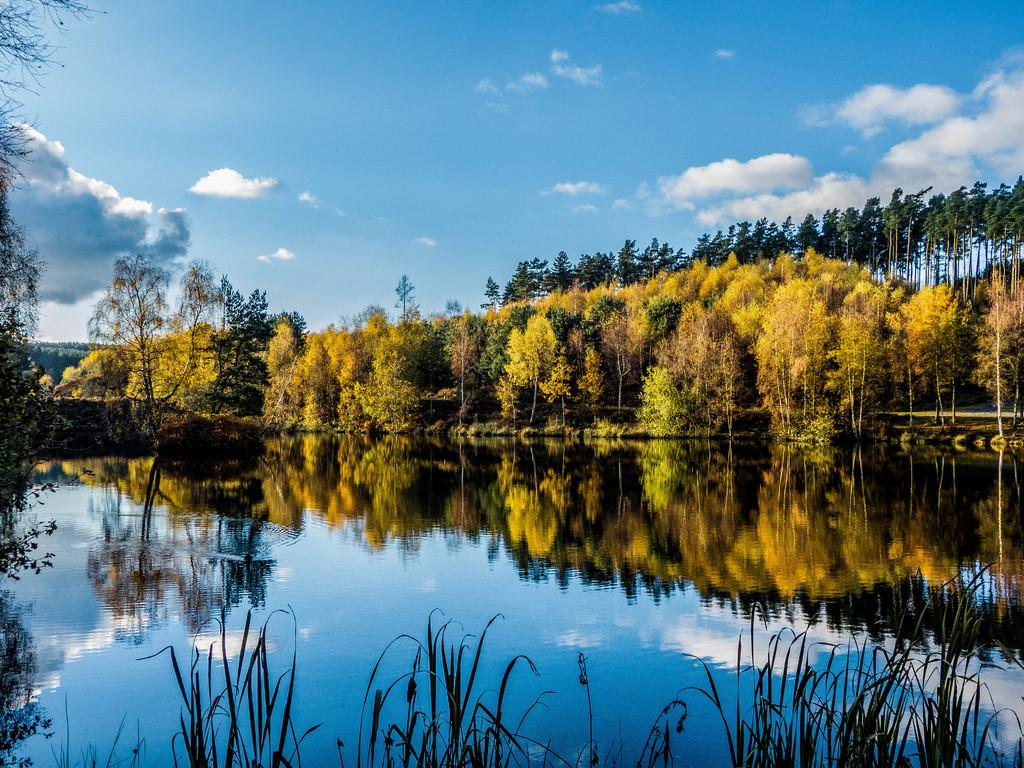What is visible in the image? Water is visible in the image. What can be seen in the background of the image? There are trees in the background of the image. What is the condition of the sky in the image? The sky is clear and visible at the top of the image. What type of drink can be seen in the root of the tree in the image? There is no drink or tree present in the image; it only features water and a clear sky. 